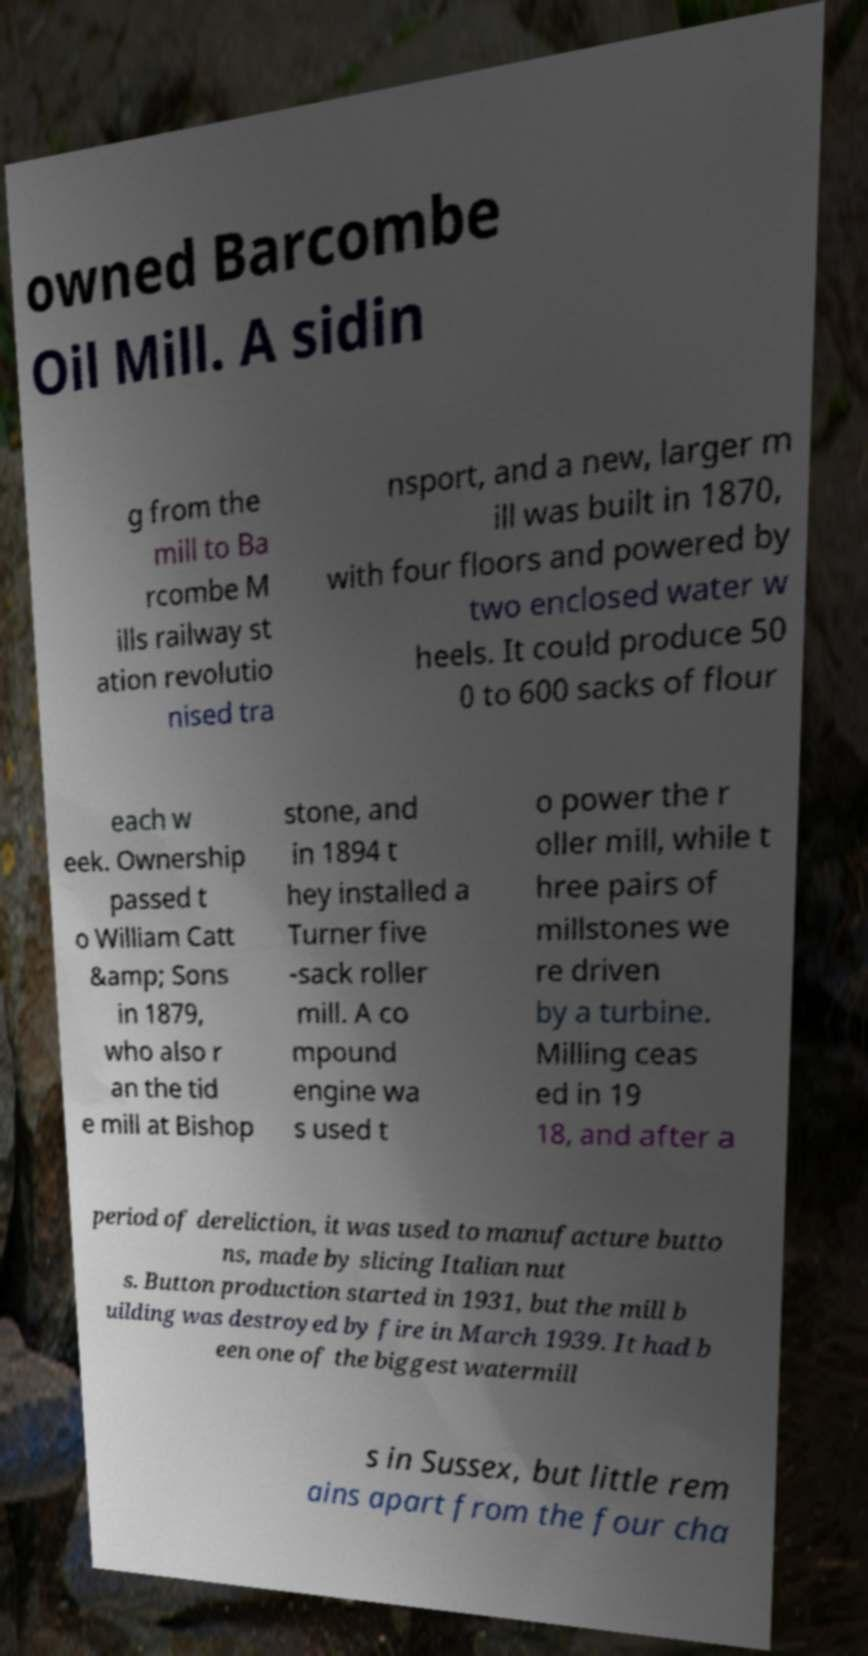I need the written content from this picture converted into text. Can you do that? owned Barcombe Oil Mill. A sidin g from the mill to Ba rcombe M ills railway st ation revolutio nised tra nsport, and a new, larger m ill was built in 1870, with four floors and powered by two enclosed water w heels. It could produce 50 0 to 600 sacks of flour each w eek. Ownership passed t o William Catt &amp; Sons in 1879, who also r an the tid e mill at Bishop stone, and in 1894 t hey installed a Turner five -sack roller mill. A co mpound engine wa s used t o power the r oller mill, while t hree pairs of millstones we re driven by a turbine. Milling ceas ed in 19 18, and after a period of dereliction, it was used to manufacture butto ns, made by slicing Italian nut s. Button production started in 1931, but the mill b uilding was destroyed by fire in March 1939. It had b een one of the biggest watermill s in Sussex, but little rem ains apart from the four cha 